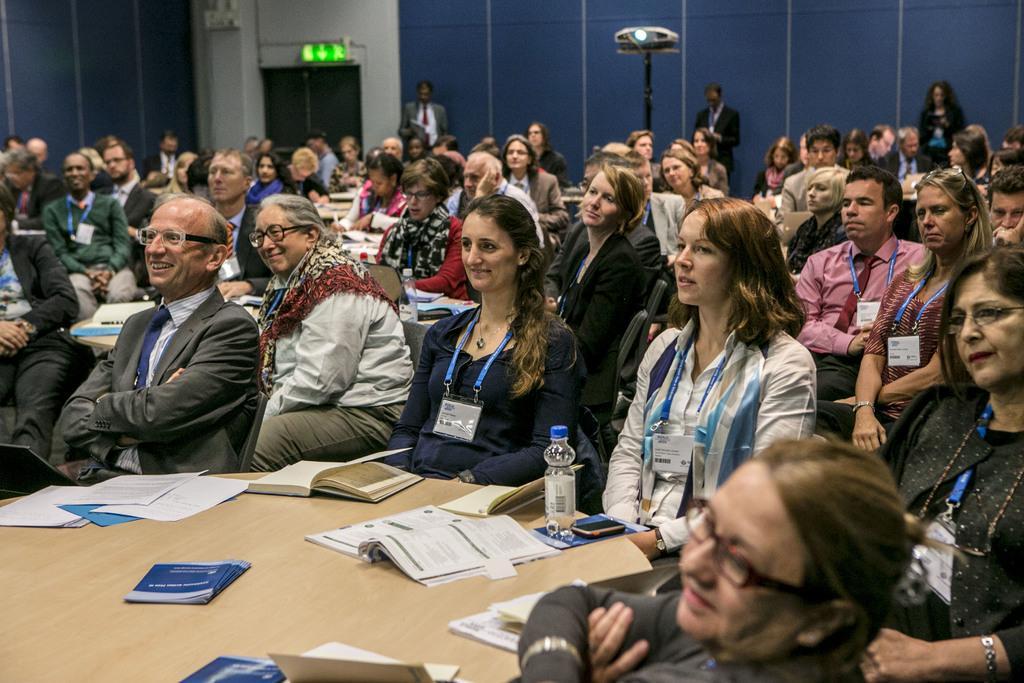How would you summarize this image in a sentence or two? In this image there are group of persons sitting. In the center there is a table, on the table there are books and there is a bottle. The woman in the center is sitting and smiling. On the left side there is a man sitting and smiling. In the background there is a projector stand and the persons in the background are standing. 